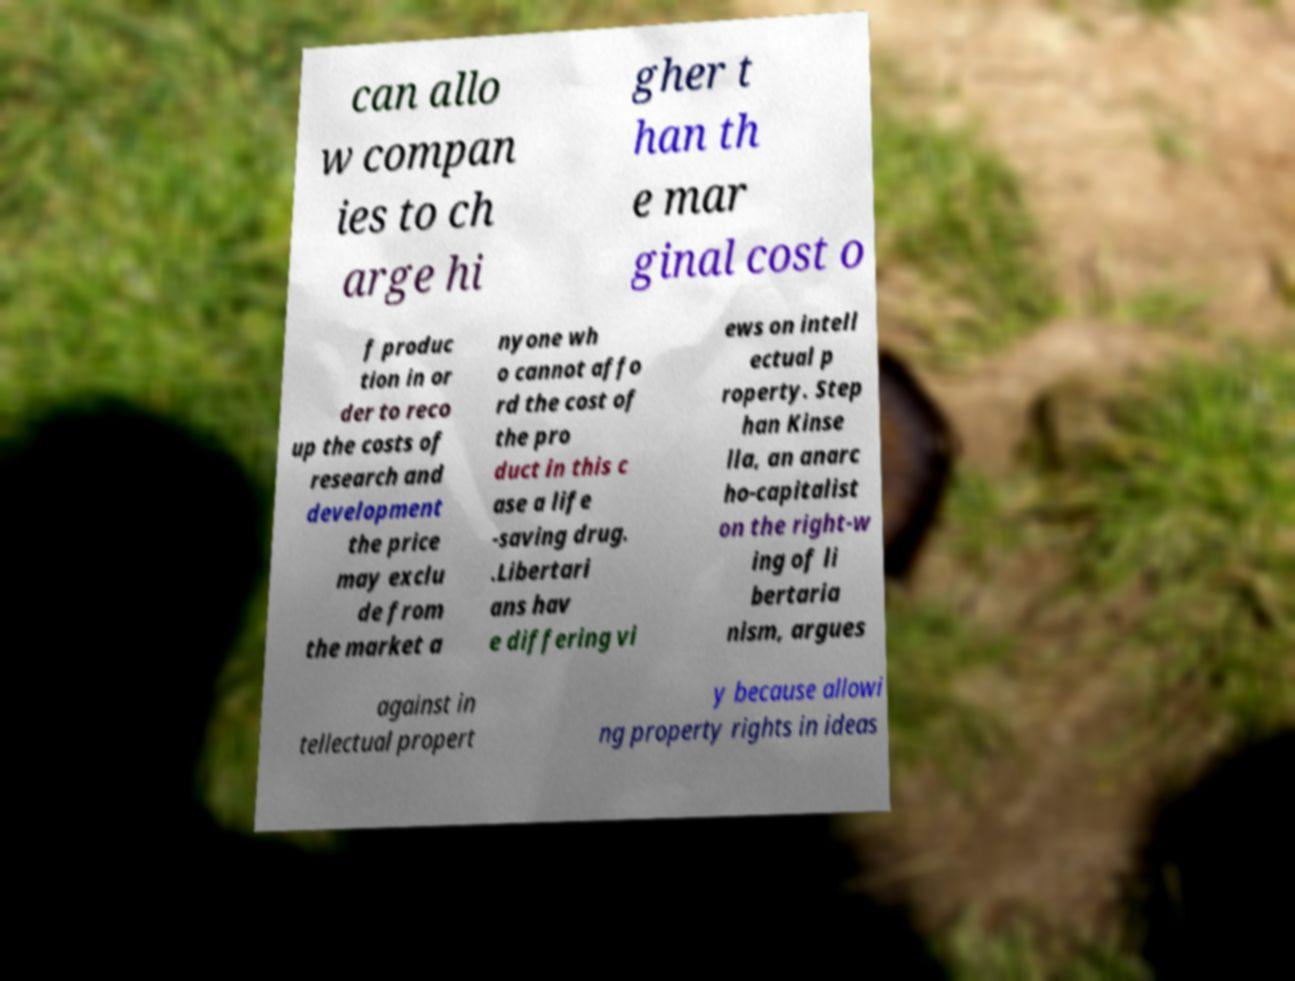Please identify and transcribe the text found in this image. can allo w compan ies to ch arge hi gher t han th e mar ginal cost o f produc tion in or der to reco up the costs of research and development the price may exclu de from the market a nyone wh o cannot affo rd the cost of the pro duct in this c ase a life -saving drug. .Libertari ans hav e differing vi ews on intell ectual p roperty. Step han Kinse lla, an anarc ho-capitalist on the right-w ing of li bertaria nism, argues against in tellectual propert y because allowi ng property rights in ideas 